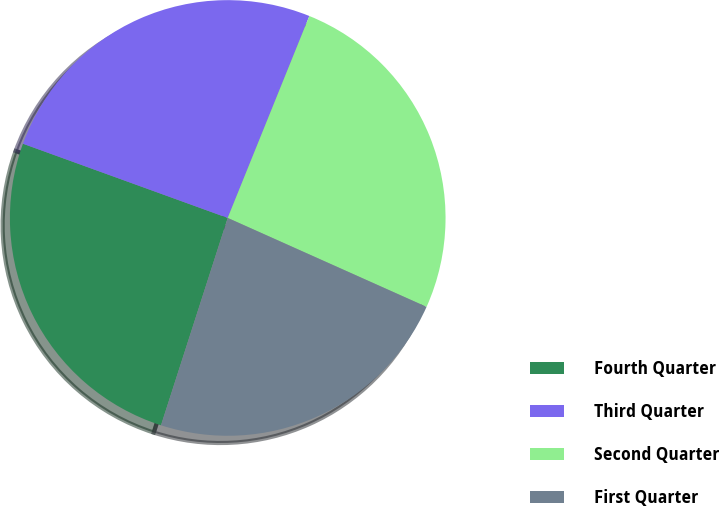Convert chart to OTSL. <chart><loc_0><loc_0><loc_500><loc_500><pie_chart><fcel>Fourth Quarter<fcel>Third Quarter<fcel>Second Quarter<fcel>First Quarter<nl><fcel>25.58%<fcel>25.58%<fcel>25.58%<fcel>23.26%<nl></chart> 